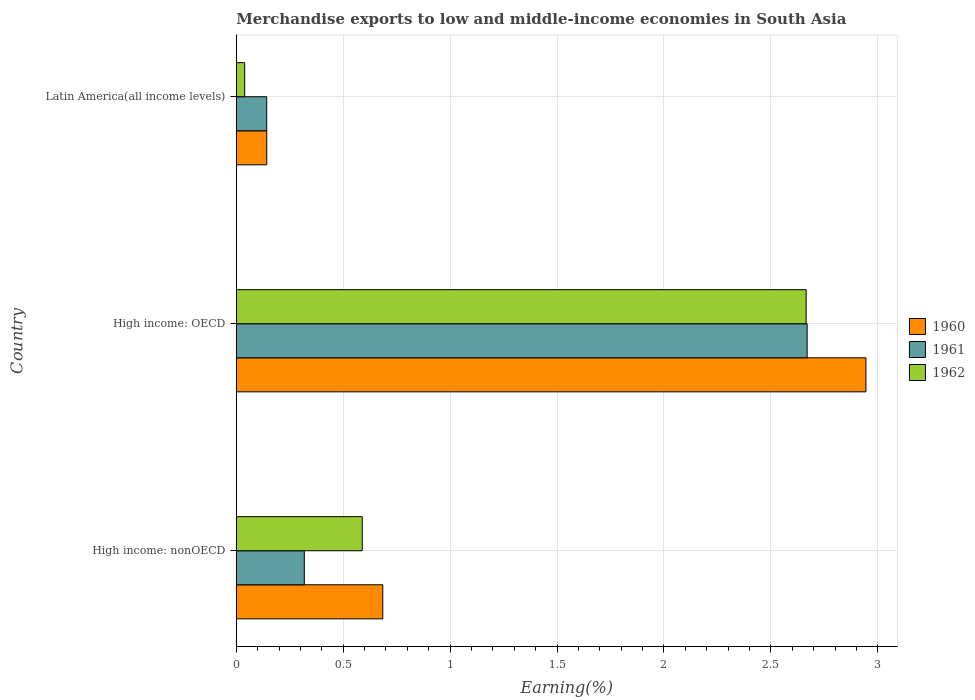How many groups of bars are there?
Provide a short and direct response. 3. How many bars are there on the 1st tick from the bottom?
Keep it short and to the point. 3. What is the label of the 3rd group of bars from the top?
Offer a very short reply. High income: nonOECD. What is the percentage of amount earned from merchandise exports in 1960 in High income: nonOECD?
Make the answer very short. 0.69. Across all countries, what is the maximum percentage of amount earned from merchandise exports in 1962?
Your answer should be compact. 2.66. Across all countries, what is the minimum percentage of amount earned from merchandise exports in 1960?
Offer a very short reply. 0.14. In which country was the percentage of amount earned from merchandise exports in 1962 maximum?
Provide a succinct answer. High income: OECD. In which country was the percentage of amount earned from merchandise exports in 1961 minimum?
Provide a short and direct response. Latin America(all income levels). What is the total percentage of amount earned from merchandise exports in 1962 in the graph?
Offer a terse response. 3.29. What is the difference between the percentage of amount earned from merchandise exports in 1960 in High income: OECD and that in Latin America(all income levels)?
Your answer should be compact. 2.8. What is the difference between the percentage of amount earned from merchandise exports in 1960 in High income: OECD and the percentage of amount earned from merchandise exports in 1961 in Latin America(all income levels)?
Make the answer very short. 2.8. What is the average percentage of amount earned from merchandise exports in 1961 per country?
Your response must be concise. 1.04. What is the difference between the percentage of amount earned from merchandise exports in 1961 and percentage of amount earned from merchandise exports in 1960 in High income: OECD?
Offer a very short reply. -0.27. What is the ratio of the percentage of amount earned from merchandise exports in 1961 in High income: OECD to that in Latin America(all income levels)?
Give a very brief answer. 18.74. Is the percentage of amount earned from merchandise exports in 1961 in High income: nonOECD less than that in Latin America(all income levels)?
Offer a very short reply. No. What is the difference between the highest and the second highest percentage of amount earned from merchandise exports in 1962?
Make the answer very short. 2.08. What is the difference between the highest and the lowest percentage of amount earned from merchandise exports in 1960?
Give a very brief answer. 2.8. Is the sum of the percentage of amount earned from merchandise exports in 1961 in High income: OECD and High income: nonOECD greater than the maximum percentage of amount earned from merchandise exports in 1960 across all countries?
Your answer should be very brief. Yes. What does the 1st bar from the bottom in High income: nonOECD represents?
Provide a short and direct response. 1960. How many bars are there?
Offer a terse response. 9. Are all the bars in the graph horizontal?
Give a very brief answer. Yes. What is the difference between two consecutive major ticks on the X-axis?
Provide a short and direct response. 0.5. Are the values on the major ticks of X-axis written in scientific E-notation?
Ensure brevity in your answer.  No. Does the graph contain grids?
Your answer should be compact. Yes. How are the legend labels stacked?
Your answer should be very brief. Vertical. What is the title of the graph?
Your answer should be very brief. Merchandise exports to low and middle-income economies in South Asia. Does "1967" appear as one of the legend labels in the graph?
Offer a terse response. No. What is the label or title of the X-axis?
Make the answer very short. Earning(%). What is the Earning(%) in 1960 in High income: nonOECD?
Your answer should be compact. 0.69. What is the Earning(%) of 1961 in High income: nonOECD?
Your answer should be very brief. 0.32. What is the Earning(%) of 1962 in High income: nonOECD?
Provide a succinct answer. 0.59. What is the Earning(%) in 1960 in High income: OECD?
Offer a terse response. 2.94. What is the Earning(%) in 1961 in High income: OECD?
Give a very brief answer. 2.67. What is the Earning(%) of 1962 in High income: OECD?
Keep it short and to the point. 2.66. What is the Earning(%) of 1960 in Latin America(all income levels)?
Offer a very short reply. 0.14. What is the Earning(%) in 1961 in Latin America(all income levels)?
Keep it short and to the point. 0.14. What is the Earning(%) in 1962 in Latin America(all income levels)?
Offer a terse response. 0.04. Across all countries, what is the maximum Earning(%) of 1960?
Your answer should be very brief. 2.94. Across all countries, what is the maximum Earning(%) of 1961?
Your response must be concise. 2.67. Across all countries, what is the maximum Earning(%) in 1962?
Your response must be concise. 2.66. Across all countries, what is the minimum Earning(%) of 1960?
Your answer should be compact. 0.14. Across all countries, what is the minimum Earning(%) in 1961?
Provide a succinct answer. 0.14. Across all countries, what is the minimum Earning(%) of 1962?
Offer a very short reply. 0.04. What is the total Earning(%) in 1960 in the graph?
Offer a terse response. 3.77. What is the total Earning(%) in 1961 in the graph?
Your answer should be very brief. 3.13. What is the total Earning(%) of 1962 in the graph?
Your answer should be compact. 3.29. What is the difference between the Earning(%) in 1960 in High income: nonOECD and that in High income: OECD?
Your answer should be very brief. -2.26. What is the difference between the Earning(%) of 1961 in High income: nonOECD and that in High income: OECD?
Make the answer very short. -2.35. What is the difference between the Earning(%) of 1962 in High income: nonOECD and that in High income: OECD?
Keep it short and to the point. -2.08. What is the difference between the Earning(%) in 1960 in High income: nonOECD and that in Latin America(all income levels)?
Offer a terse response. 0.54. What is the difference between the Earning(%) of 1961 in High income: nonOECD and that in Latin America(all income levels)?
Provide a short and direct response. 0.18. What is the difference between the Earning(%) in 1962 in High income: nonOECD and that in Latin America(all income levels)?
Keep it short and to the point. 0.55. What is the difference between the Earning(%) in 1960 in High income: OECD and that in Latin America(all income levels)?
Make the answer very short. 2.8. What is the difference between the Earning(%) of 1961 in High income: OECD and that in Latin America(all income levels)?
Ensure brevity in your answer.  2.53. What is the difference between the Earning(%) of 1962 in High income: OECD and that in Latin America(all income levels)?
Provide a short and direct response. 2.63. What is the difference between the Earning(%) in 1960 in High income: nonOECD and the Earning(%) in 1961 in High income: OECD?
Make the answer very short. -1.98. What is the difference between the Earning(%) of 1960 in High income: nonOECD and the Earning(%) of 1962 in High income: OECD?
Your response must be concise. -1.98. What is the difference between the Earning(%) in 1961 in High income: nonOECD and the Earning(%) in 1962 in High income: OECD?
Give a very brief answer. -2.35. What is the difference between the Earning(%) of 1960 in High income: nonOECD and the Earning(%) of 1961 in Latin America(all income levels)?
Offer a very short reply. 0.54. What is the difference between the Earning(%) of 1960 in High income: nonOECD and the Earning(%) of 1962 in Latin America(all income levels)?
Make the answer very short. 0.65. What is the difference between the Earning(%) of 1961 in High income: nonOECD and the Earning(%) of 1962 in Latin America(all income levels)?
Give a very brief answer. 0.28. What is the difference between the Earning(%) in 1960 in High income: OECD and the Earning(%) in 1961 in Latin America(all income levels)?
Make the answer very short. 2.8. What is the difference between the Earning(%) of 1960 in High income: OECD and the Earning(%) of 1962 in Latin America(all income levels)?
Keep it short and to the point. 2.91. What is the difference between the Earning(%) of 1961 in High income: OECD and the Earning(%) of 1962 in Latin America(all income levels)?
Your response must be concise. 2.63. What is the average Earning(%) of 1960 per country?
Offer a terse response. 1.26. What is the average Earning(%) in 1961 per country?
Ensure brevity in your answer.  1.04. What is the average Earning(%) of 1962 per country?
Give a very brief answer. 1.1. What is the difference between the Earning(%) in 1960 and Earning(%) in 1961 in High income: nonOECD?
Your response must be concise. 0.37. What is the difference between the Earning(%) of 1960 and Earning(%) of 1962 in High income: nonOECD?
Make the answer very short. 0.1. What is the difference between the Earning(%) of 1961 and Earning(%) of 1962 in High income: nonOECD?
Make the answer very short. -0.27. What is the difference between the Earning(%) of 1960 and Earning(%) of 1961 in High income: OECD?
Offer a very short reply. 0.27. What is the difference between the Earning(%) in 1960 and Earning(%) in 1962 in High income: OECD?
Provide a short and direct response. 0.28. What is the difference between the Earning(%) in 1961 and Earning(%) in 1962 in High income: OECD?
Make the answer very short. 0. What is the difference between the Earning(%) of 1960 and Earning(%) of 1962 in Latin America(all income levels)?
Provide a succinct answer. 0.1. What is the difference between the Earning(%) in 1961 and Earning(%) in 1962 in Latin America(all income levels)?
Ensure brevity in your answer.  0.1. What is the ratio of the Earning(%) of 1960 in High income: nonOECD to that in High income: OECD?
Keep it short and to the point. 0.23. What is the ratio of the Earning(%) of 1961 in High income: nonOECD to that in High income: OECD?
Your answer should be compact. 0.12. What is the ratio of the Earning(%) in 1962 in High income: nonOECD to that in High income: OECD?
Provide a succinct answer. 0.22. What is the ratio of the Earning(%) of 1960 in High income: nonOECD to that in Latin America(all income levels)?
Offer a terse response. 4.8. What is the ratio of the Earning(%) in 1961 in High income: nonOECD to that in Latin America(all income levels)?
Give a very brief answer. 2.23. What is the ratio of the Earning(%) of 1962 in High income: nonOECD to that in Latin America(all income levels)?
Give a very brief answer. 14.98. What is the ratio of the Earning(%) in 1960 in High income: OECD to that in Latin America(all income levels)?
Ensure brevity in your answer.  20.64. What is the ratio of the Earning(%) of 1961 in High income: OECD to that in Latin America(all income levels)?
Provide a succinct answer. 18.74. What is the ratio of the Earning(%) in 1962 in High income: OECD to that in Latin America(all income levels)?
Your response must be concise. 67.77. What is the difference between the highest and the second highest Earning(%) of 1960?
Provide a short and direct response. 2.26. What is the difference between the highest and the second highest Earning(%) in 1961?
Provide a succinct answer. 2.35. What is the difference between the highest and the second highest Earning(%) of 1962?
Your response must be concise. 2.08. What is the difference between the highest and the lowest Earning(%) in 1960?
Offer a terse response. 2.8. What is the difference between the highest and the lowest Earning(%) of 1961?
Make the answer very short. 2.53. What is the difference between the highest and the lowest Earning(%) of 1962?
Provide a short and direct response. 2.63. 